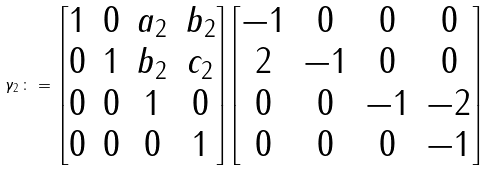<formula> <loc_0><loc_0><loc_500><loc_500>\gamma _ { 2 } \, \colon = \, \begin{bmatrix} 1 & 0 & a _ { 2 } & b _ { 2 } \\ 0 & 1 & b _ { 2 } & c _ { 2 } \\ 0 & 0 & 1 & 0 \\ 0 & 0 & 0 & 1 \end{bmatrix} \begin{bmatrix} - 1 & 0 & 0 & 0 \\ 2 & - 1 & 0 & 0 \\ 0 & 0 & - 1 & - 2 \\ 0 & 0 & 0 & - 1 \end{bmatrix}</formula> 